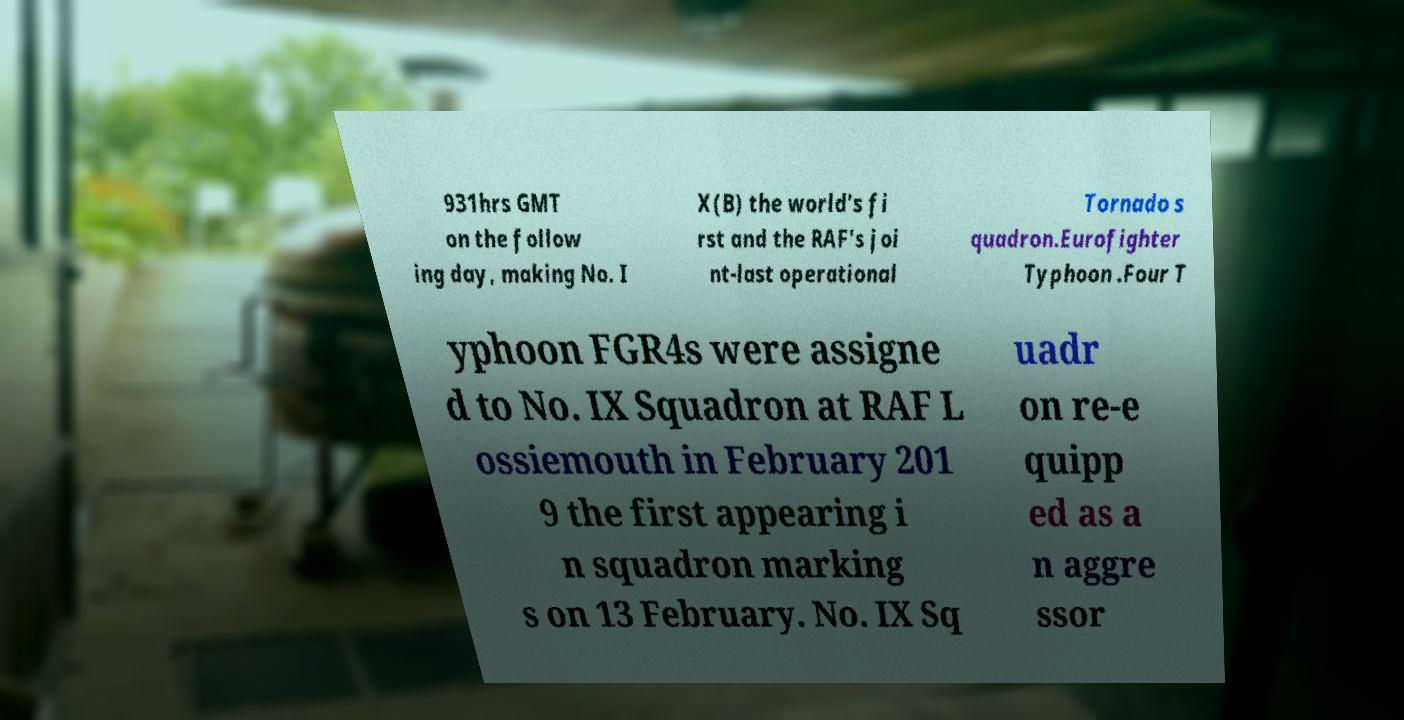I need the written content from this picture converted into text. Can you do that? 931hrs GMT on the follow ing day, making No. I X(B) the world's fi rst and the RAF's joi nt-last operational Tornado s quadron.Eurofighter Typhoon .Four T yphoon FGR4s were assigne d to No. IX Squadron at RAF L ossiemouth in February 201 9 the first appearing i n squadron marking s on 13 February. No. IX Sq uadr on re-e quipp ed as a n aggre ssor 